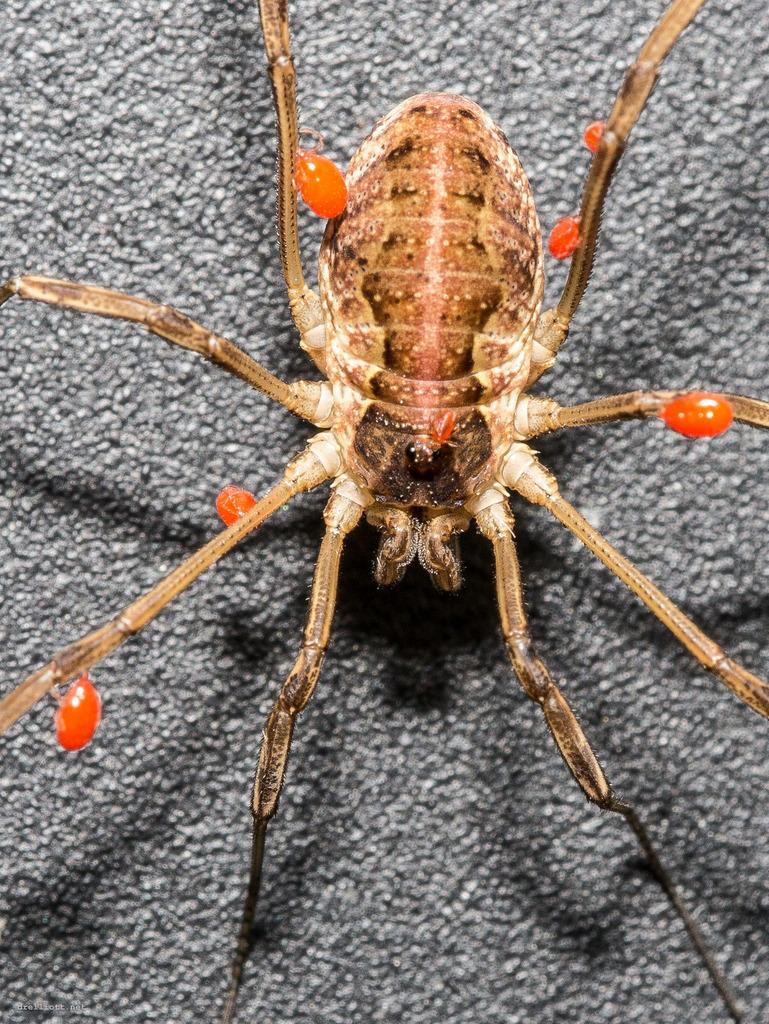What type of creature is present in the image? There is a spider in the image. What type of linen is being used to clean the spider in the image? There is no linen present in the image, nor is the spider being cleaned. 